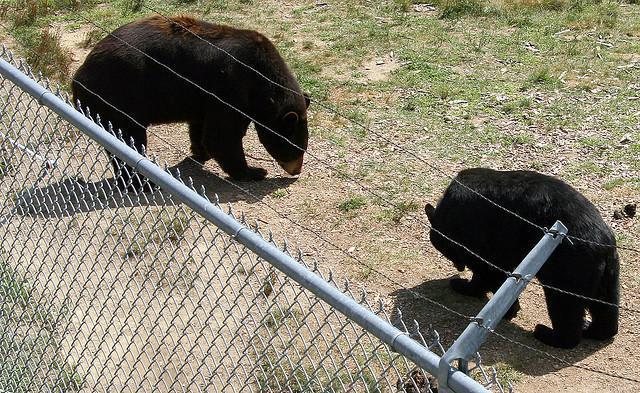How many bears can be seen?
Give a very brief answer. 2. How many zebras are in the picture?
Give a very brief answer. 0. 